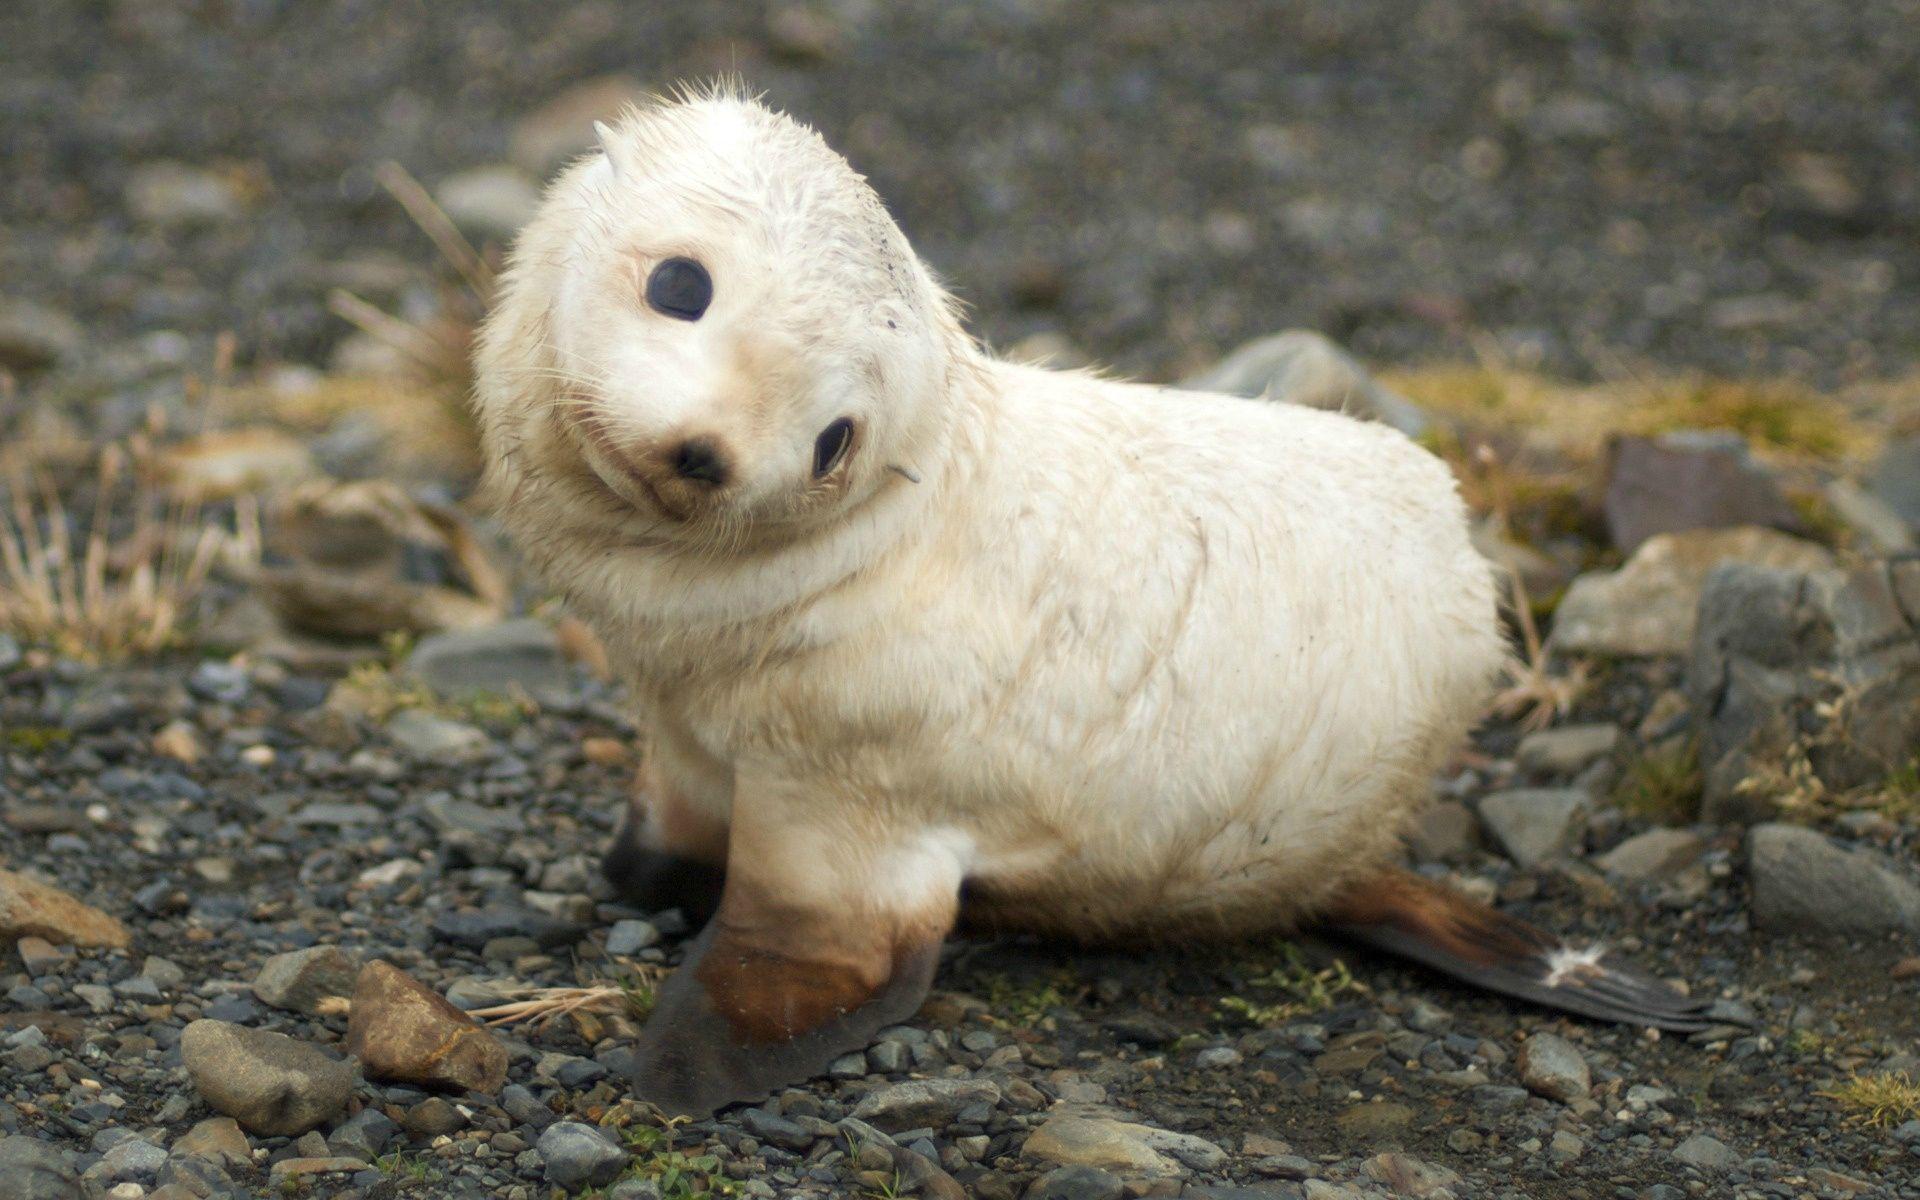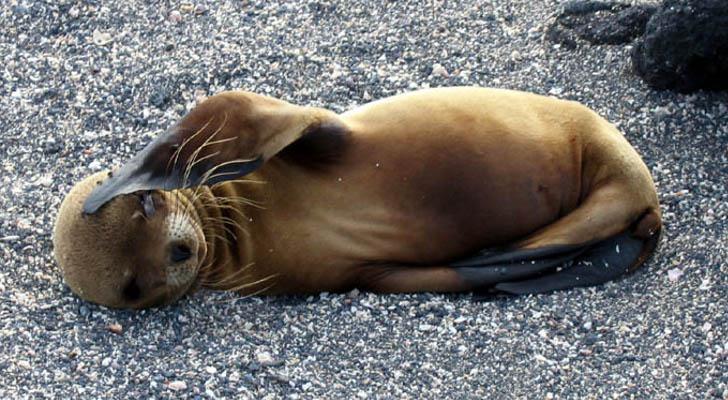The first image is the image on the left, the second image is the image on the right. Analyze the images presented: Is the assertion "the baby seal on the right is lying down." valid? Answer yes or no. Yes. 